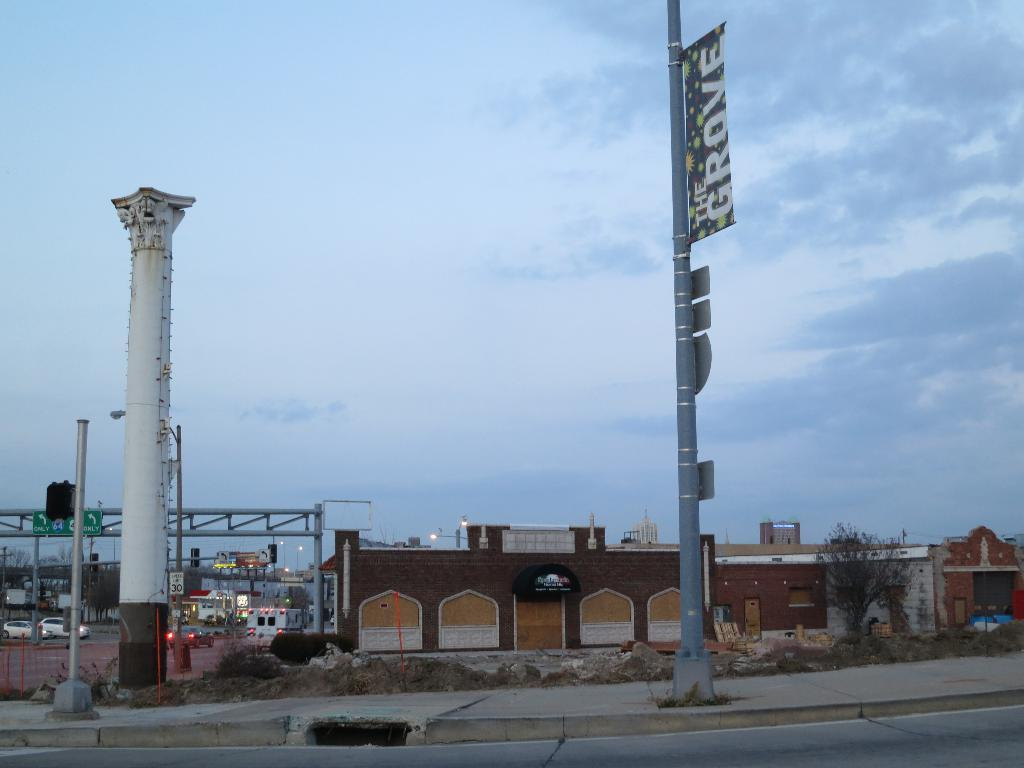What can be seen in the foreground of the image? There is a road and a footpath in the foreground of the image. What is located in the middle of the image? Houses and cars are visible in the middle of the image. What is visible at the top of the image? The sky is visible at the top of the image. How many dogs are making a statement with their fangs in the image? There are no dogs or fangs present in the image. What type of statement is being made by the fangs in the image? There are no fangs or statements present in the image. 